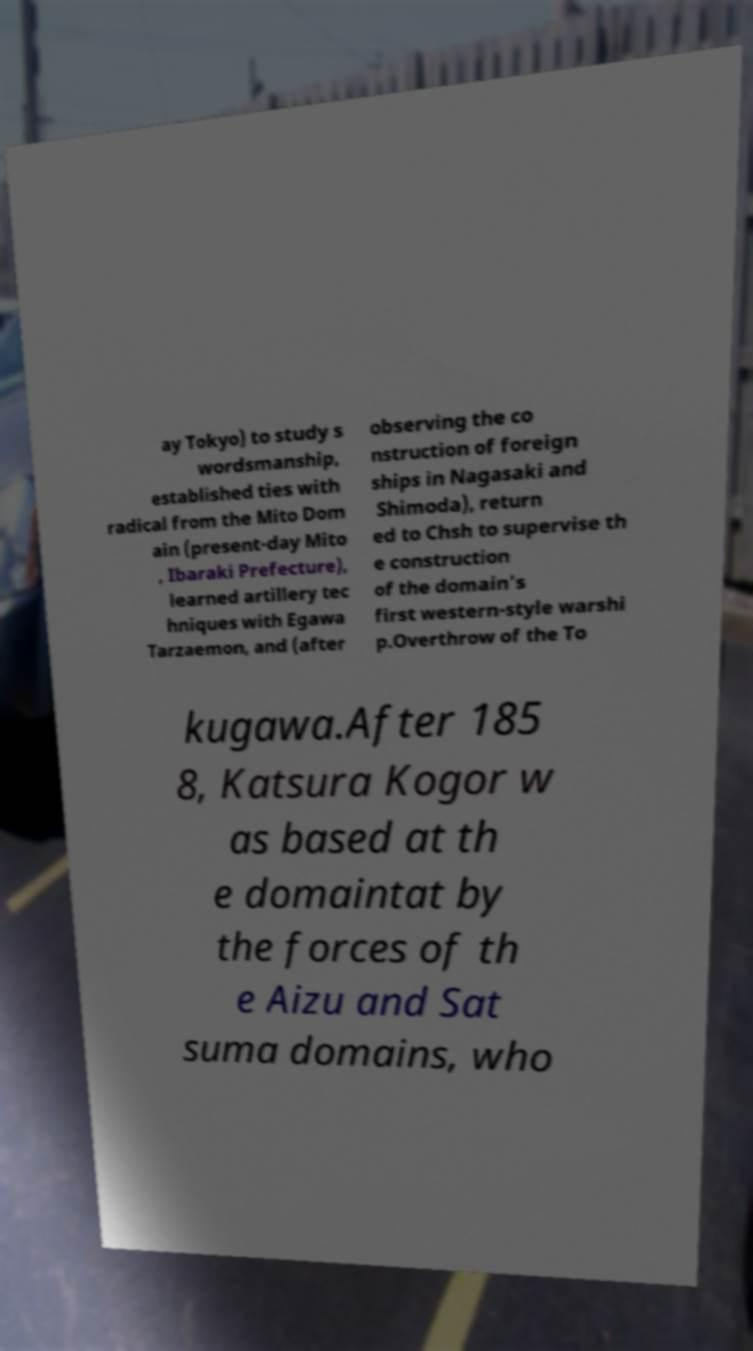For documentation purposes, I need the text within this image transcribed. Could you provide that? ay Tokyo) to study s wordsmanship, established ties with radical from the Mito Dom ain (present-day Mito , Ibaraki Prefecture), learned artillery tec hniques with Egawa Tarzaemon, and (after observing the co nstruction of foreign ships in Nagasaki and Shimoda), return ed to Chsh to supervise th e construction of the domain's first western-style warshi p.Overthrow of the To kugawa.After 185 8, Katsura Kogor w as based at th e domaintat by the forces of th e Aizu and Sat suma domains, who 